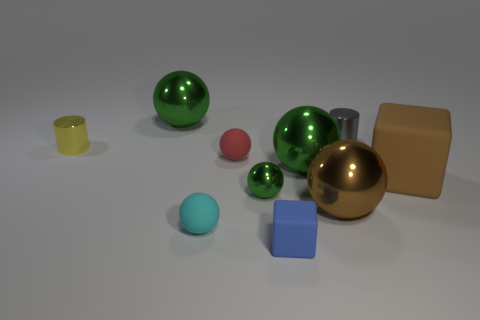Subtract all small red spheres. How many spheres are left? 5 Subtract all cyan spheres. How many spheres are left? 5 Subtract 5 balls. How many balls are left? 1 Subtract all red balls. Subtract all green blocks. How many balls are left? 5 Subtract all cyan cubes. How many yellow cylinders are left? 1 Subtract all big green metal objects. Subtract all small shiny cylinders. How many objects are left? 6 Add 2 big brown rubber blocks. How many big brown rubber blocks are left? 3 Add 1 big brown metal balls. How many big brown metal balls exist? 2 Subtract 0 blue cylinders. How many objects are left? 10 Subtract all blocks. How many objects are left? 8 